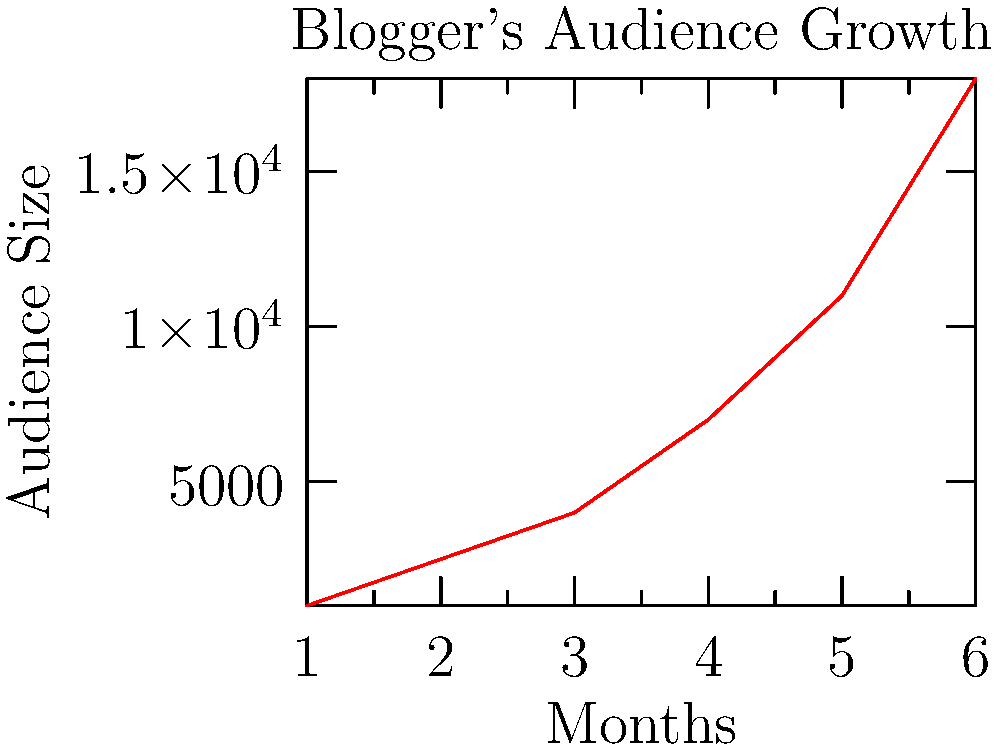As a book editor considering the blogger's compilation for publication, what key insight about the blogger's audience growth can you derive from the line chart, and how might this influence your decision to publish? To analyze the growth of the blogger's audience and make an informed decision about publishing, we should follow these steps:

1. Observe the overall trend: The line chart shows a clear upward trend, indicating consistent growth in the blogger's audience over time.

2. Analyze the rate of growth: The slope of the line becomes steeper as time progresses, suggesting that the growth rate is accelerating.

3. Calculate the growth rate:
   Initial audience (Month 1): 1,000
   Final audience (Month 6): 18,000
   Total growth: 18,000 - 1,000 = 17,000
   Percentage growth: (17,000 / 1,000) * 100 = 1,700%

4. Assess the market potential: The rapid growth indicates a strong and expanding readership, which is favorable for potential book sales.

5. Consider the content's appeal: The accelerating growth suggests that the blogger's content is resonating increasingly well with the audience, potentially translating to a successful book.

6. Evaluate the timing: With the audience size reaching 18,000 by Month 6, it might be an opportune time to capitalize on the growing popularity by publishing the anthology.

The key insight is that the blogger's audience is experiencing exponential growth, increasing by 1,700% over six months. This rapid expansion suggests a high level of reader engagement and a potentially lucrative market for a published anthology.
Answer: Exponential audience growth of 1,700% over six months, indicating high market potential for the anthology. 